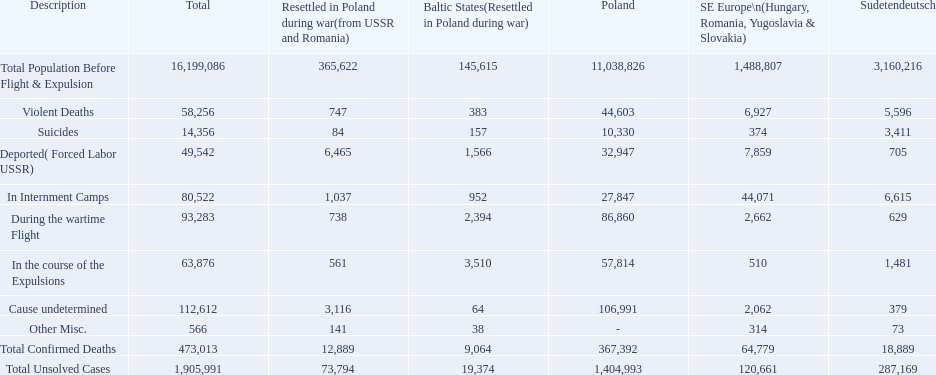What was the cause of the most deaths? Cause undetermined. Could you help me parse every detail presented in this table? {'header': ['Description', 'Total', 'Resettled in Poland during war(from USSR and Romania)', 'Baltic States(Resettled in Poland during war)', 'Poland', 'SE Europe\\n(Hungary, Romania, Yugoslavia & Slovakia)', 'Sudetendeutsch'], 'rows': [['Total Population Before Flight & Expulsion', '16,199,086', '365,622', '145,615', '11,038,826', '1,488,807', '3,160,216'], ['Violent Deaths', '58,256', '747', '383', '44,603', '6,927', '5,596'], ['Suicides', '14,356', '84', '157', '10,330', '374', '3,411'], ['Deported( Forced Labor USSR)', '49,542', '6,465', '1,566', '32,947', '7,859', '705'], ['In Internment Camps', '80,522', '1,037', '952', '27,847', '44,071', '6,615'], ['During the wartime Flight', '93,283', '738', '2,394', '86,860', '2,662', '629'], ['In the course of the Expulsions', '63,876', '561', '3,510', '57,814', '510', '1,481'], ['Cause undetermined', '112,612', '3,116', '64', '106,991', '2,062', '379'], ['Other Misc.', '566', '141', '38', '-', '314', '73'], ['Total Confirmed Deaths', '473,013', '12,889', '9,064', '367,392', '64,779', '18,889'], ['Total Unsolved Cases', '1,905,991', '73,794', '19,374', '1,404,993', '120,661', '287,169']]} 